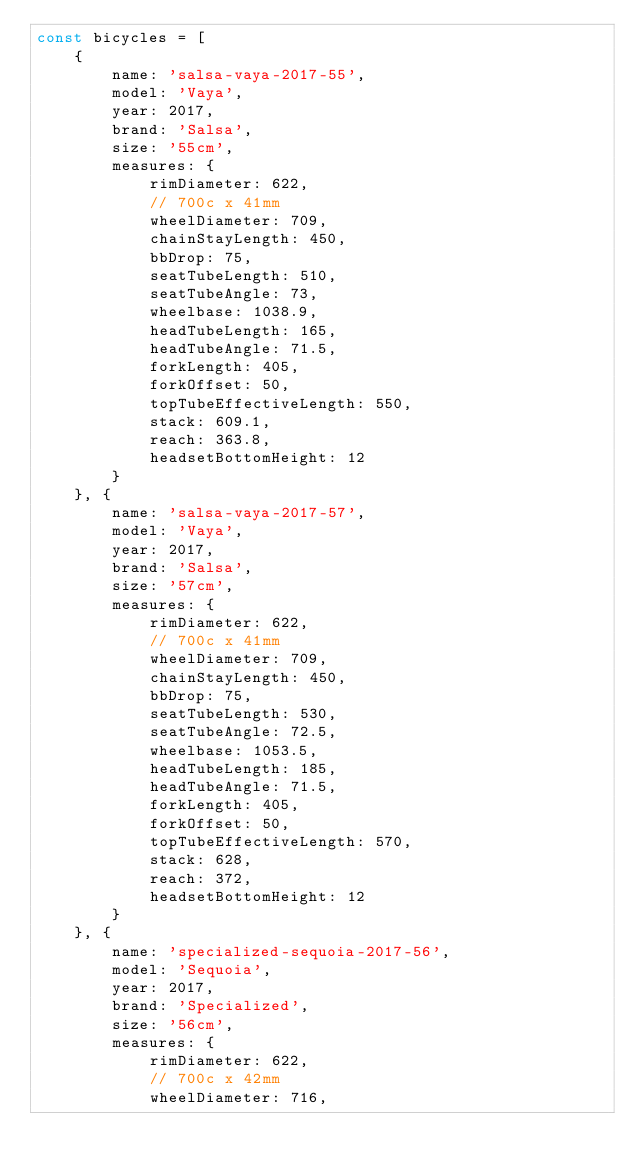<code> <loc_0><loc_0><loc_500><loc_500><_JavaScript_>const bicycles = [
    {
        name: 'salsa-vaya-2017-55',
        model: 'Vaya',
        year: 2017,
        brand: 'Salsa',
        size: '55cm',
        measures: {
            rimDiameter: 622,
            // 700c x 41mm
            wheelDiameter: 709,
            chainStayLength: 450,
            bbDrop: 75,
            seatTubeLength: 510,
            seatTubeAngle: 73,
            wheelbase: 1038.9,
            headTubeLength: 165,
            headTubeAngle: 71.5,
            forkLength: 405,
            forkOffset: 50,
            topTubeEffectiveLength: 550,
            stack: 609.1,
            reach: 363.8,
            headsetBottomHeight: 12
        }
    }, {
        name: 'salsa-vaya-2017-57',
        model: 'Vaya',
        year: 2017,
        brand: 'Salsa',
        size: '57cm',
        measures: {
            rimDiameter: 622,
            // 700c x 41mm
            wheelDiameter: 709,
            chainStayLength: 450,
            bbDrop: 75,
            seatTubeLength: 530,
            seatTubeAngle: 72.5,
            wheelbase: 1053.5,
            headTubeLength: 185,
            headTubeAngle: 71.5,
            forkLength: 405,
            forkOffset: 50,
            topTubeEffectiveLength: 570,
            stack: 628,
            reach: 372,
            headsetBottomHeight: 12
        }
    }, {
        name: 'specialized-sequoia-2017-56',
        model: 'Sequoia',
        year: 2017,
        brand: 'Specialized',
        size: '56cm',
        measures: {
            rimDiameter: 622,
            // 700c x 42mm
            wheelDiameter: 716,</code> 